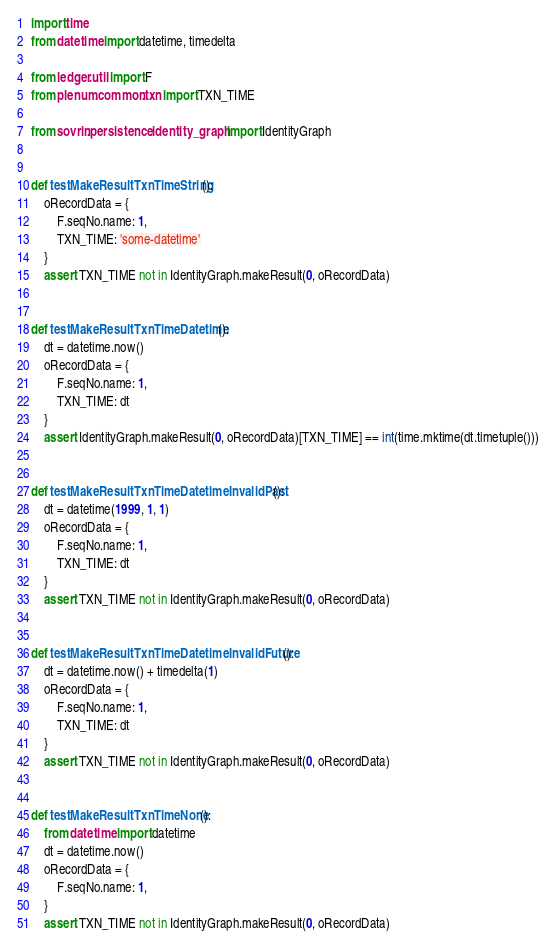Convert code to text. <code><loc_0><loc_0><loc_500><loc_500><_Python_>import time
from datetime import datetime, timedelta

from ledger.util import F
from plenum.common.txn import TXN_TIME

from sovrin.persistence.identity_graph import IdentityGraph


def testMakeResultTxnTimeString():
    oRecordData = {
        F.seqNo.name: 1,
        TXN_TIME: 'some-datetime'
    }
    assert TXN_TIME not in IdentityGraph.makeResult(0, oRecordData)


def testMakeResultTxnTimeDatetime():
    dt = datetime.now()
    oRecordData = {
        F.seqNo.name: 1,
        TXN_TIME: dt
    }
    assert IdentityGraph.makeResult(0, oRecordData)[TXN_TIME] == int(time.mktime(dt.timetuple()))


def testMakeResultTxnTimeDatetimeInvalidPast():
    dt = datetime(1999, 1, 1)
    oRecordData = {
        F.seqNo.name: 1,
        TXN_TIME: dt
    }
    assert TXN_TIME not in IdentityGraph.makeResult(0, oRecordData)


def testMakeResultTxnTimeDatetimeInvalidFuture():
    dt = datetime.now() + timedelta(1)
    oRecordData = {
        F.seqNo.name: 1,
        TXN_TIME: dt
    }
    assert TXN_TIME not in IdentityGraph.makeResult(0, oRecordData)


def testMakeResultTxnTimeNone():
    from datetime import datetime
    dt = datetime.now()
    oRecordData = {
        F.seqNo.name: 1,
    }
    assert TXN_TIME not in IdentityGraph.makeResult(0, oRecordData)
</code> 